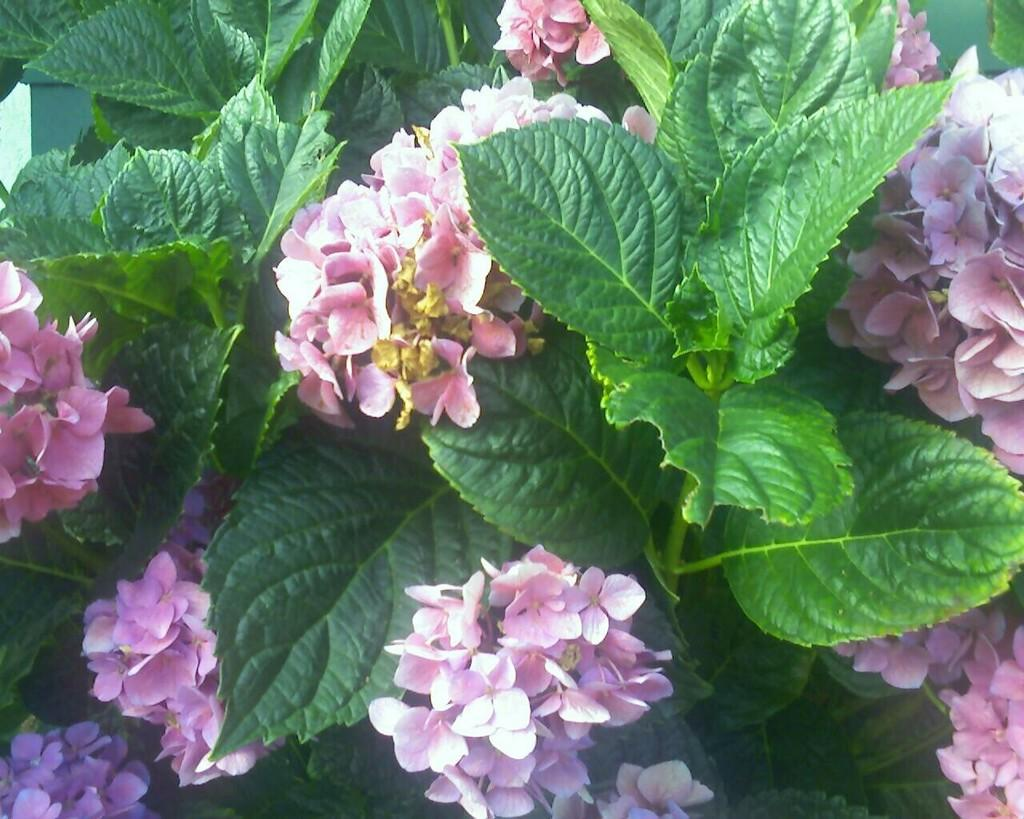What type of living organisms can be seen in the image? Plants can be seen in the image. What specific features do the plants have? The plants have flowers and leaves. What type of throne is visible in the image? There is no throne present in the image; it features plants with flowers and leaves. How many cherries can be seen on the plants in the image? There are no cherries present in the image; it features plants with flowers and leaves. 